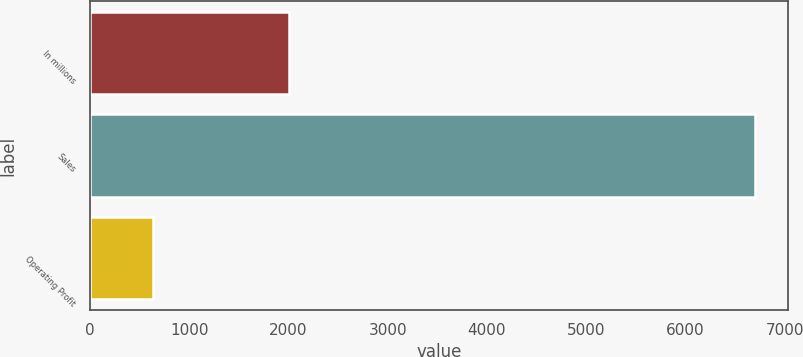<chart> <loc_0><loc_0><loc_500><loc_500><bar_chart><fcel>In millions<fcel>Sales<fcel>Operating Profit<nl><fcel>2006<fcel>6700<fcel>636<nl></chart> 